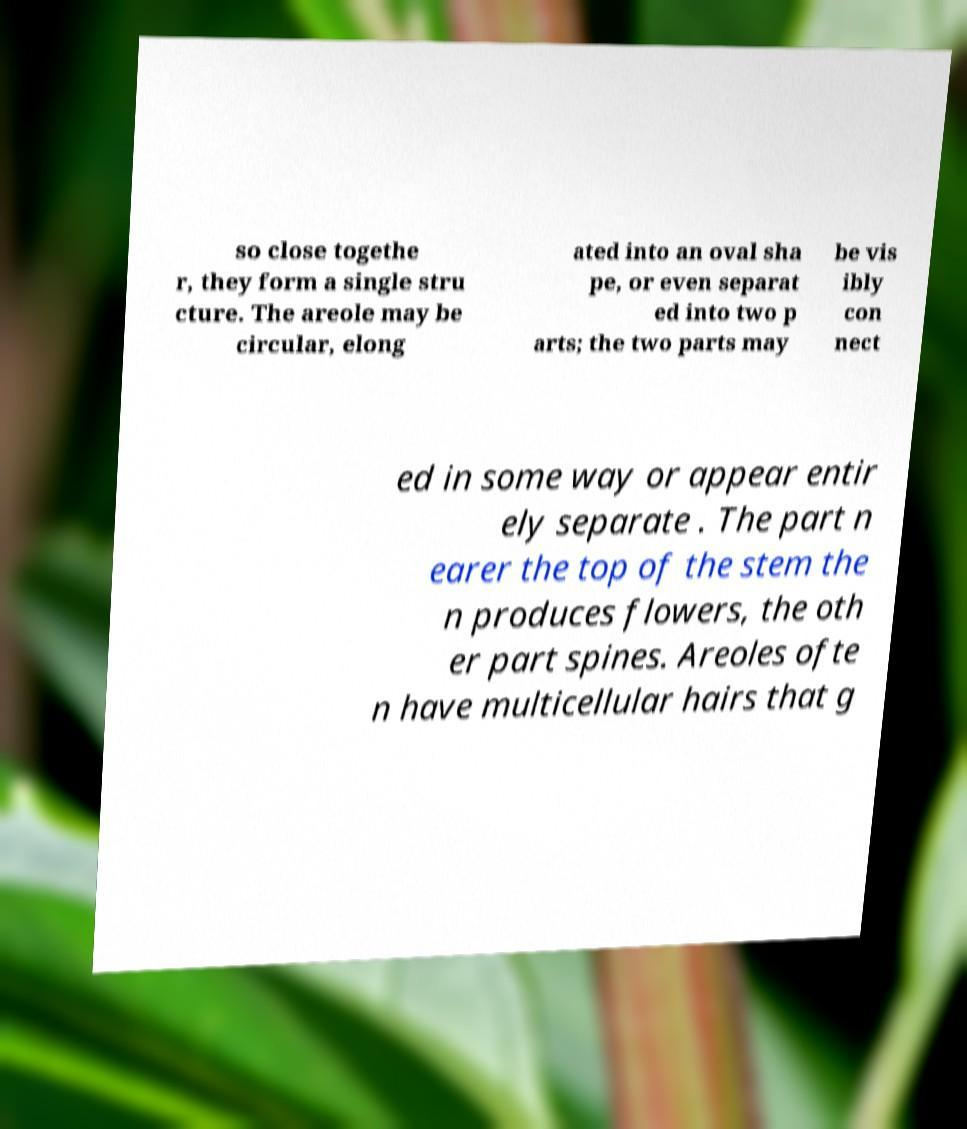There's text embedded in this image that I need extracted. Can you transcribe it verbatim? so close togethe r, they form a single stru cture. The areole may be circular, elong ated into an oval sha pe, or even separat ed into two p arts; the two parts may be vis ibly con nect ed in some way or appear entir ely separate . The part n earer the top of the stem the n produces flowers, the oth er part spines. Areoles ofte n have multicellular hairs that g 